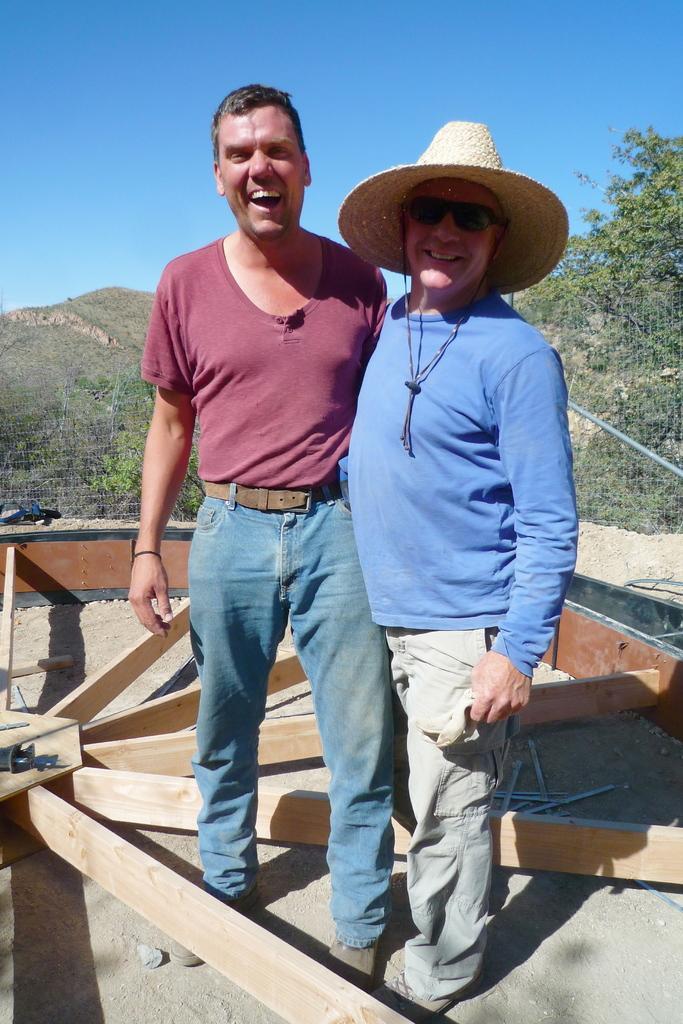Can you describe this image briefly? There are two men standing, there are wooden planks and other objects in the foreground area of the image, there are trees, a mountain and the sky in the background. 